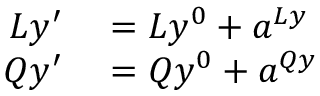Convert formula to latex. <formula><loc_0><loc_0><loc_500><loc_500>\begin{array} { r l } { L y ^ { \prime } } & = L y ^ { 0 } + a ^ { L y } } \\ { Q y ^ { \prime } } & = Q y ^ { 0 } + a ^ { Q y } } \end{array}</formula> 